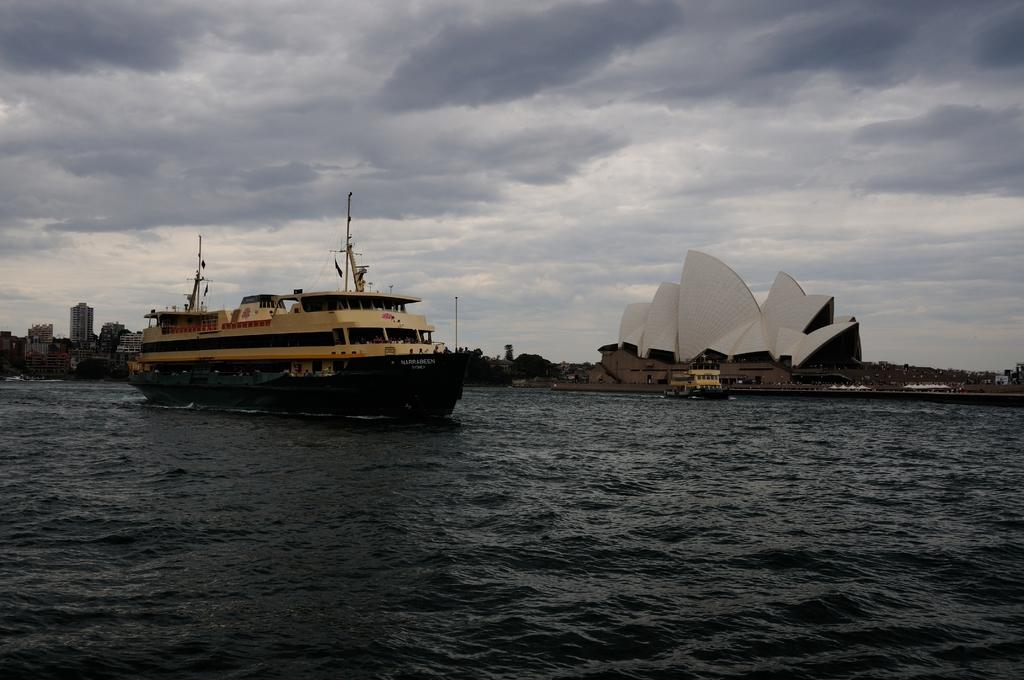What is on the water in the image? There are ships on the water in the image. What type of structures can be seen in the image? There are buildings in the image. What other natural elements are present in the image? There are trees in the image. What else can be seen in the image? There are poles in the image. What is visible in the background of the image? The sky is visible in the background of the image, and there are clouds in the sky. What type of apparatus is being used to harvest yams in the image? There is no apparatus for harvesting yams present in the image. Can you tell me how many airplanes are visible at the airport in the image? There is no airport or airplanes visible in the image. 